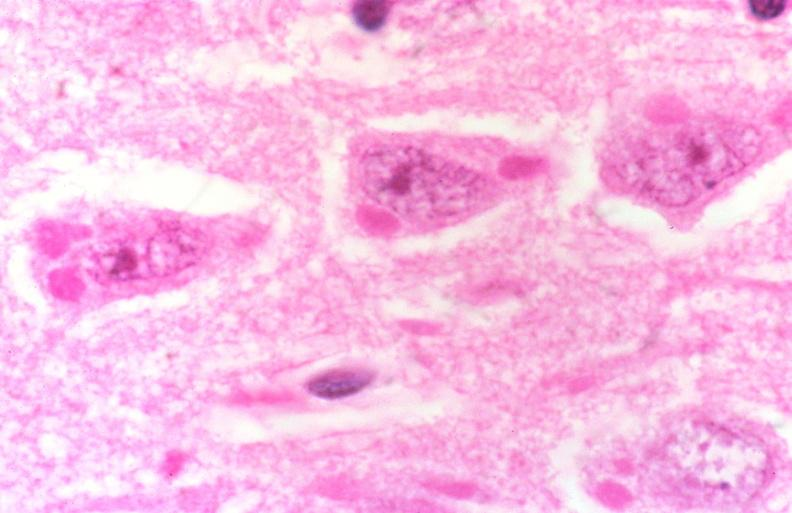does supernumerary digits show rabies, negri bodies?
Answer the question using a single word or phrase. No 